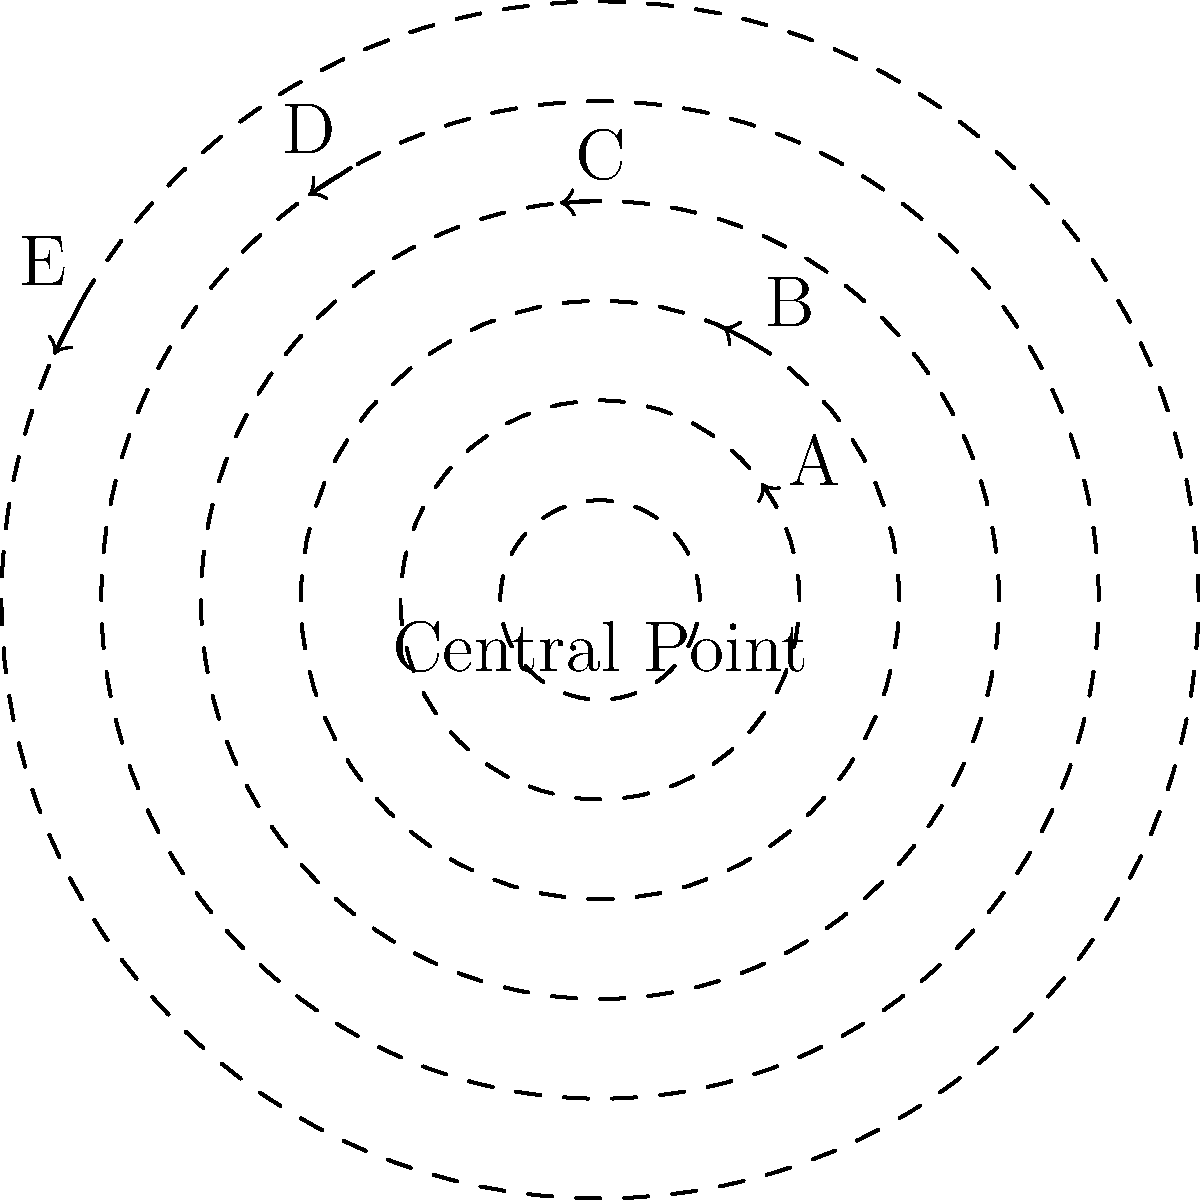In an emergency evacuation scenario, five different routes (A, B, C, D, and E) are available from a central point. The polar coordinates graph shows the routes, where the distance from the center represents the route length (in km), and the angle represents the direction. Which route should be prioritized for the most efficient evacuation, considering both distance and direction? To determine the most efficient evacuation route, we need to consider both the distance and direction of each route. Let's analyze each route:

1. Route A: $(r, \theta) = (2, \pi/6)$
   - Shortest distance (2 km)
   - Direction is close to east

2. Route B: $(r, \theta) = (3, \pi/3)$
   - Moderate distance (3 km)
   - Direction is northeast

3. Route C: $(r, \theta) = (4, \pi/2)$
   - Longer distance (4 km)
   - Direction is due north

4. Route D: $(r, \theta) = (5, 2\pi/3)$
   - Long distance (5 km)
   - Direction is northwest

5. Route E: $(r, \theta) = (6, 5\pi/6)$
   - Longest distance (6 km)
   - Direction is close to west

Considering both factors:
1. Distance: Route A is the shortest, which is favorable for quick evacuation.
2. Direction: Routes A and B offer directions away from the other routes, potentially reducing congestion.

Among these, Route A stands out as the most efficient choice because:
- It has the shortest distance, allowing for the quickest evacuation.
- Its direction (close to east) is distinct from other routes, potentially reducing traffic and congestion.
- Being the shortest route, it may require fewer resources and personnel to manage.

Therefore, Route A should be prioritized for the most efficient evacuation.
Answer: Route A 